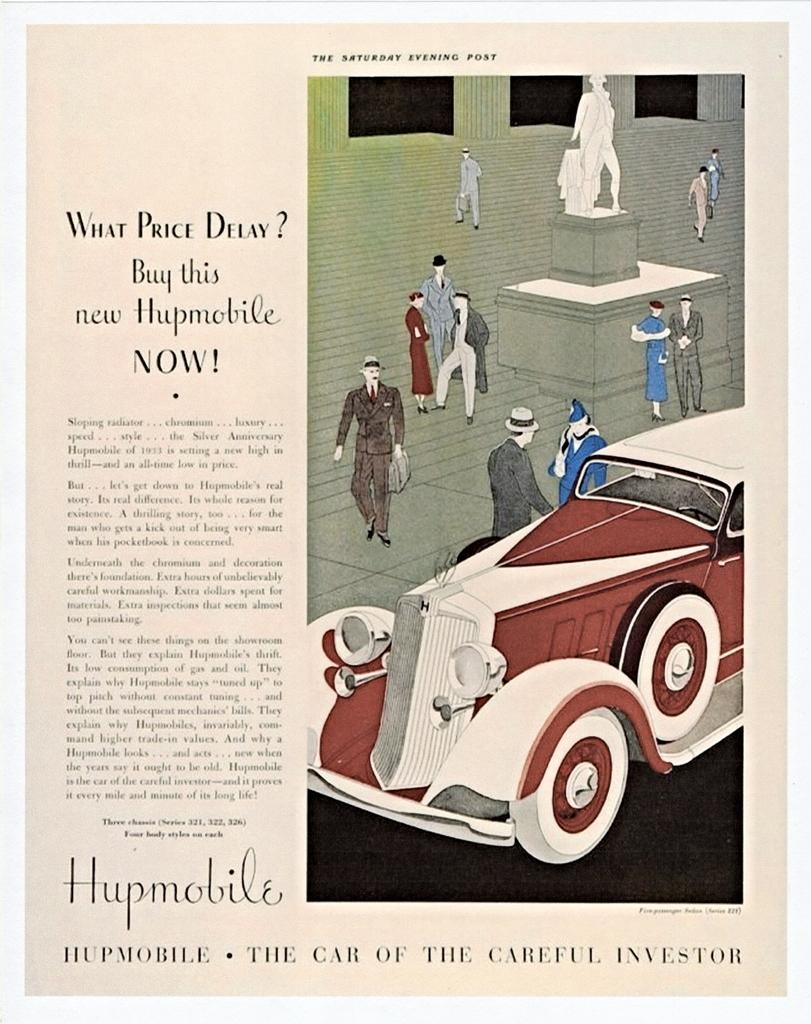What is present on the left side of the image? There is a poster in the image. What can be seen on the right side of the poster? There is a cartoon image on the right side of the poster. What elements are included in the cartoon image? The cartoon image contains a car, a statue, a woman, a man, and other objects. What is located on the right side of the image? There is a passage on the right side of the image. How does the sky appear in the image? There is no sky present in the image; it is a poster with a cartoon image and a passage. 